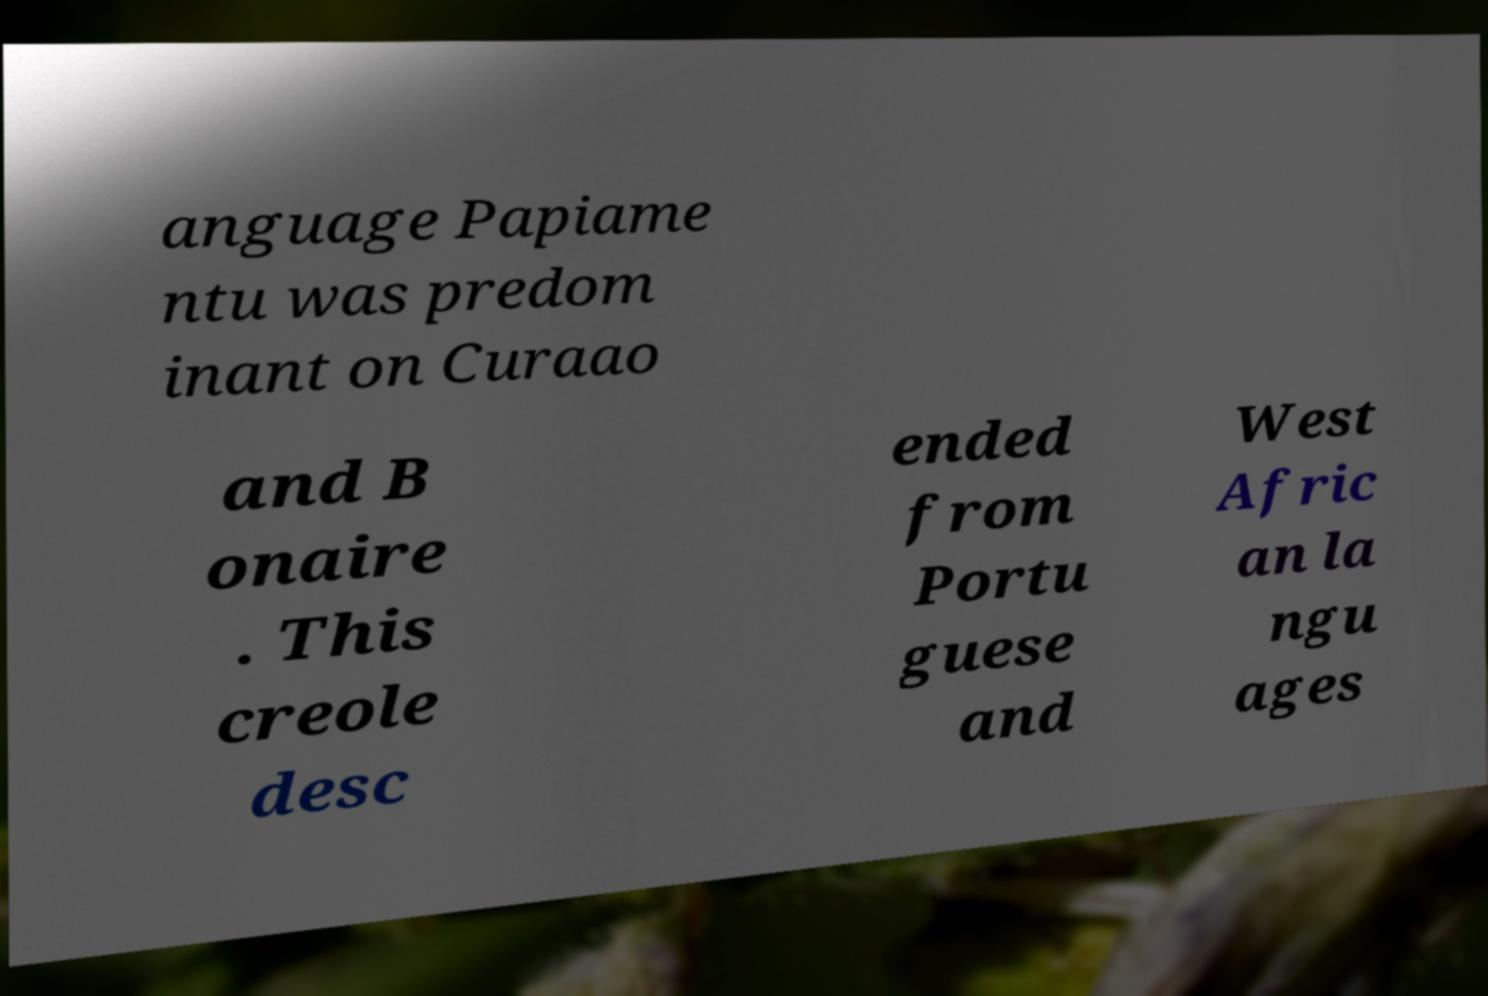Could you extract and type out the text from this image? anguage Papiame ntu was predom inant on Curaao and B onaire . This creole desc ended from Portu guese and West Afric an la ngu ages 